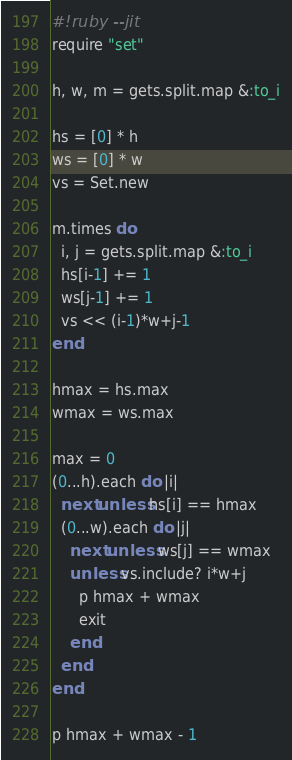<code> <loc_0><loc_0><loc_500><loc_500><_Ruby_>#!ruby --jit
require "set"

h, w, m = gets.split.map &:to_i

hs = [0] * h
ws = [0] * w
vs = Set.new

m.times do
  i, j = gets.split.map &:to_i
  hs[i-1] += 1
  ws[j-1] += 1
  vs << (i-1)*w+j-1
end

hmax = hs.max
wmax = ws.max

max = 0
(0...h).each do |i|
  next unless hs[i] == hmax
  (0...w).each do |j|
    next unless ws[j] == wmax
    unless vs.include? i*w+j
      p hmax + wmax
      exit
    end
  end
end

p hmax + wmax - 1</code> 